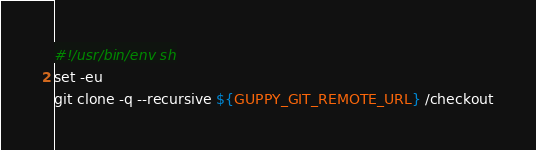<code> <loc_0><loc_0><loc_500><loc_500><_Bash_>#!/usr/bin/env sh
set -eu
git clone -q --recursive ${GUPPY_GIT_REMOTE_URL} /checkout
</code> 